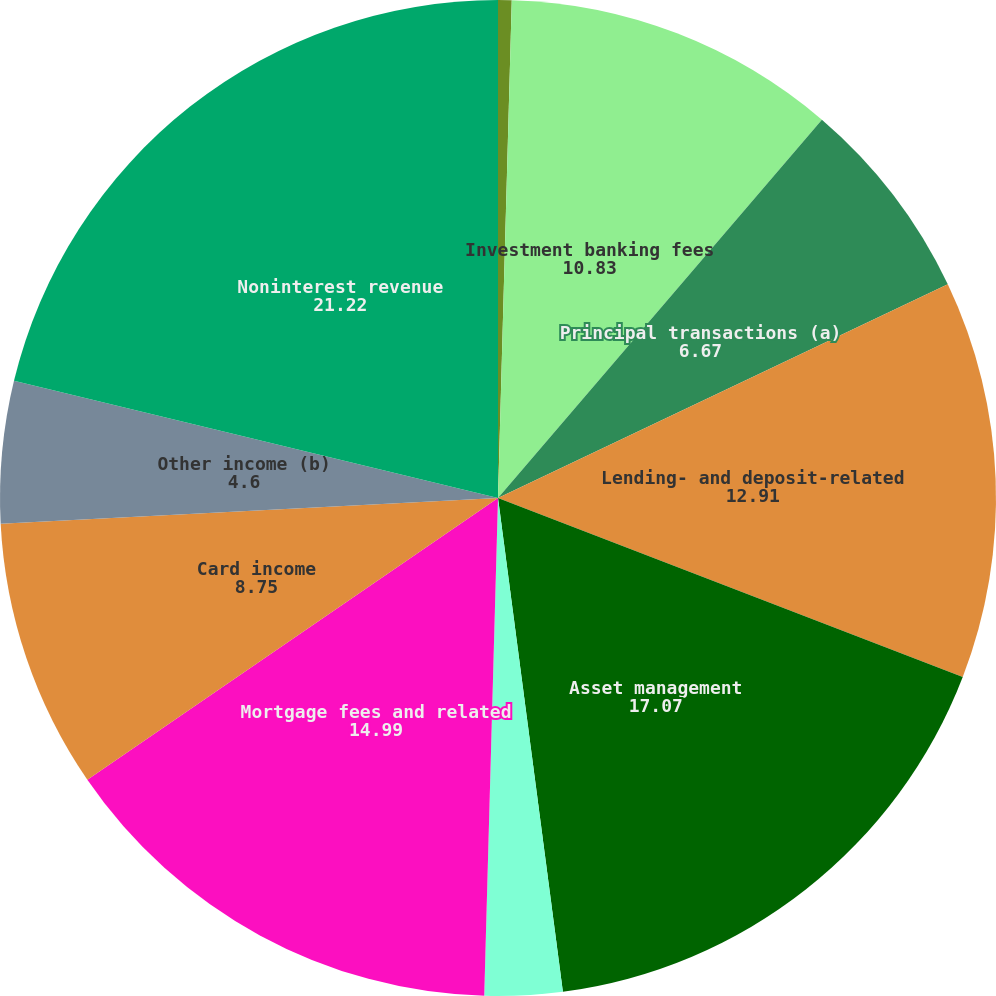Convert chart to OTSL. <chart><loc_0><loc_0><loc_500><loc_500><pie_chart><fcel>(in millions)<fcel>Investment banking fees<fcel>Principal transactions (a)<fcel>Lending- and deposit-related<fcel>Asset management<fcel>Securities gains<fcel>Mortgage fees and related<fcel>Card income<fcel>Other income (b)<fcel>Noninterest revenue<nl><fcel>0.44%<fcel>10.83%<fcel>6.67%<fcel>12.91%<fcel>17.07%<fcel>2.52%<fcel>14.99%<fcel>8.75%<fcel>4.6%<fcel>21.22%<nl></chart> 